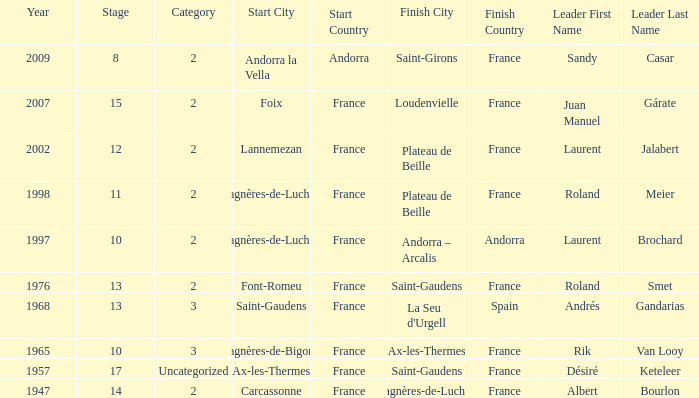Give the Finish for a Stage that is larger than 15 Saint-Gaudens. 